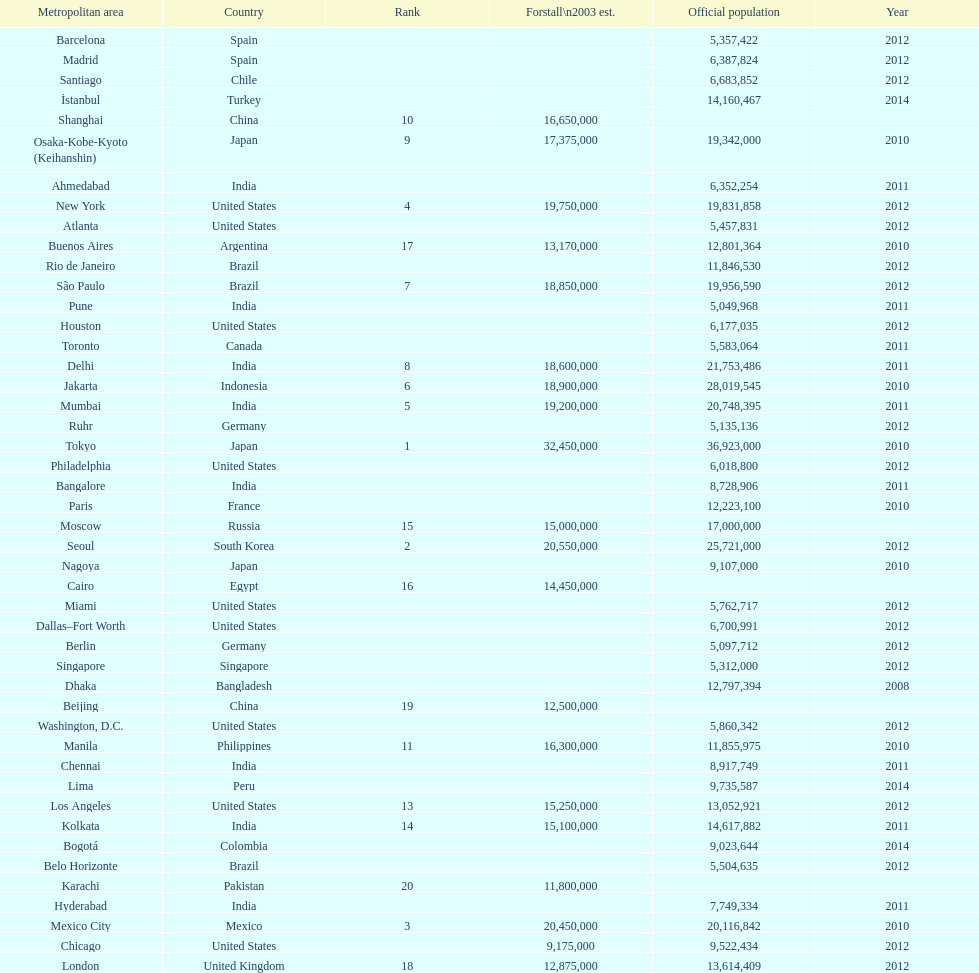State a city within the same country as bangalore. Ahmedabad. Parse the table in full. {'header': ['Metropolitan area', 'Country', 'Rank', 'Forstall\\n2003 est.', 'Official population', 'Year'], 'rows': [['Barcelona', 'Spain', '', '', '5,357,422', '2012'], ['Madrid', 'Spain', '', '', '6,387,824', '2012'], ['Santiago', 'Chile', '', '', '6,683,852', '2012'], ['İstanbul', 'Turkey', '', '', '14,160,467', '2014'], ['Shanghai', 'China', '10', '16,650,000', '', ''], ['Osaka-Kobe-Kyoto (Keihanshin)', 'Japan', '9', '17,375,000', '19,342,000', '2010'], ['Ahmedabad', 'India', '', '', '6,352,254', '2011'], ['New York', 'United States', '4', '19,750,000', '19,831,858', '2012'], ['Atlanta', 'United States', '', '', '5,457,831', '2012'], ['Buenos Aires', 'Argentina', '17', '13,170,000', '12,801,364', '2010'], ['Rio de Janeiro', 'Brazil', '', '', '11,846,530', '2012'], ['São Paulo', 'Brazil', '7', '18,850,000', '19,956,590', '2012'], ['Pune', 'India', '', '', '5,049,968', '2011'], ['Houston', 'United States', '', '', '6,177,035', '2012'], ['Toronto', 'Canada', '', '', '5,583,064', '2011'], ['Delhi', 'India', '8', '18,600,000', '21,753,486', '2011'], ['Jakarta', 'Indonesia', '6', '18,900,000', '28,019,545', '2010'], ['Mumbai', 'India', '5', '19,200,000', '20,748,395', '2011'], ['Ruhr', 'Germany', '', '', '5,135,136', '2012'], ['Tokyo', 'Japan', '1', '32,450,000', '36,923,000', '2010'], ['Philadelphia', 'United States', '', '', '6,018,800', '2012'], ['Bangalore', 'India', '', '', '8,728,906', '2011'], ['Paris', 'France', '', '', '12,223,100', '2010'], ['Moscow', 'Russia', '15', '15,000,000', '17,000,000', ''], ['Seoul', 'South Korea', '2', '20,550,000', '25,721,000', '2012'], ['Nagoya', 'Japan', '', '', '9,107,000', '2010'], ['Cairo', 'Egypt', '16', '14,450,000', '', ''], ['Miami', 'United States', '', '', '5,762,717', '2012'], ['Dallas–Fort Worth', 'United States', '', '', '6,700,991', '2012'], ['Berlin', 'Germany', '', '', '5,097,712', '2012'], ['Singapore', 'Singapore', '', '', '5,312,000', '2012'], ['Dhaka', 'Bangladesh', '', '', '12,797,394', '2008'], ['Beijing', 'China', '19', '12,500,000', '', ''], ['Washington, D.C.', 'United States', '', '', '5,860,342', '2012'], ['Manila', 'Philippines', '11', '16,300,000', '11,855,975', '2010'], ['Chennai', 'India', '', '', '8,917,749', '2011'], ['Lima', 'Peru', '', '', '9,735,587', '2014'], ['Los Angeles', 'United States', '13', '15,250,000', '13,052,921', '2012'], ['Kolkata', 'India', '14', '15,100,000', '14,617,882', '2011'], ['Bogotá', 'Colombia', '', '', '9,023,644', '2014'], ['Belo Horizonte', 'Brazil', '', '', '5,504,635', '2012'], ['Karachi', 'Pakistan', '20', '11,800,000', '', ''], ['Hyderabad', 'India', '', '', '7,749,334', '2011'], ['Mexico City', 'Mexico', '3', '20,450,000', '20,116,842', '2010'], ['Chicago', 'United States', '', '9,175,000', '9,522,434', '2012'], ['London', 'United Kingdom', '18', '12,875,000', '13,614,409', '2012']]} 